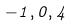Convert formula to latex. <formula><loc_0><loc_0><loc_500><loc_500>- 1 , 0 , 4</formula> 